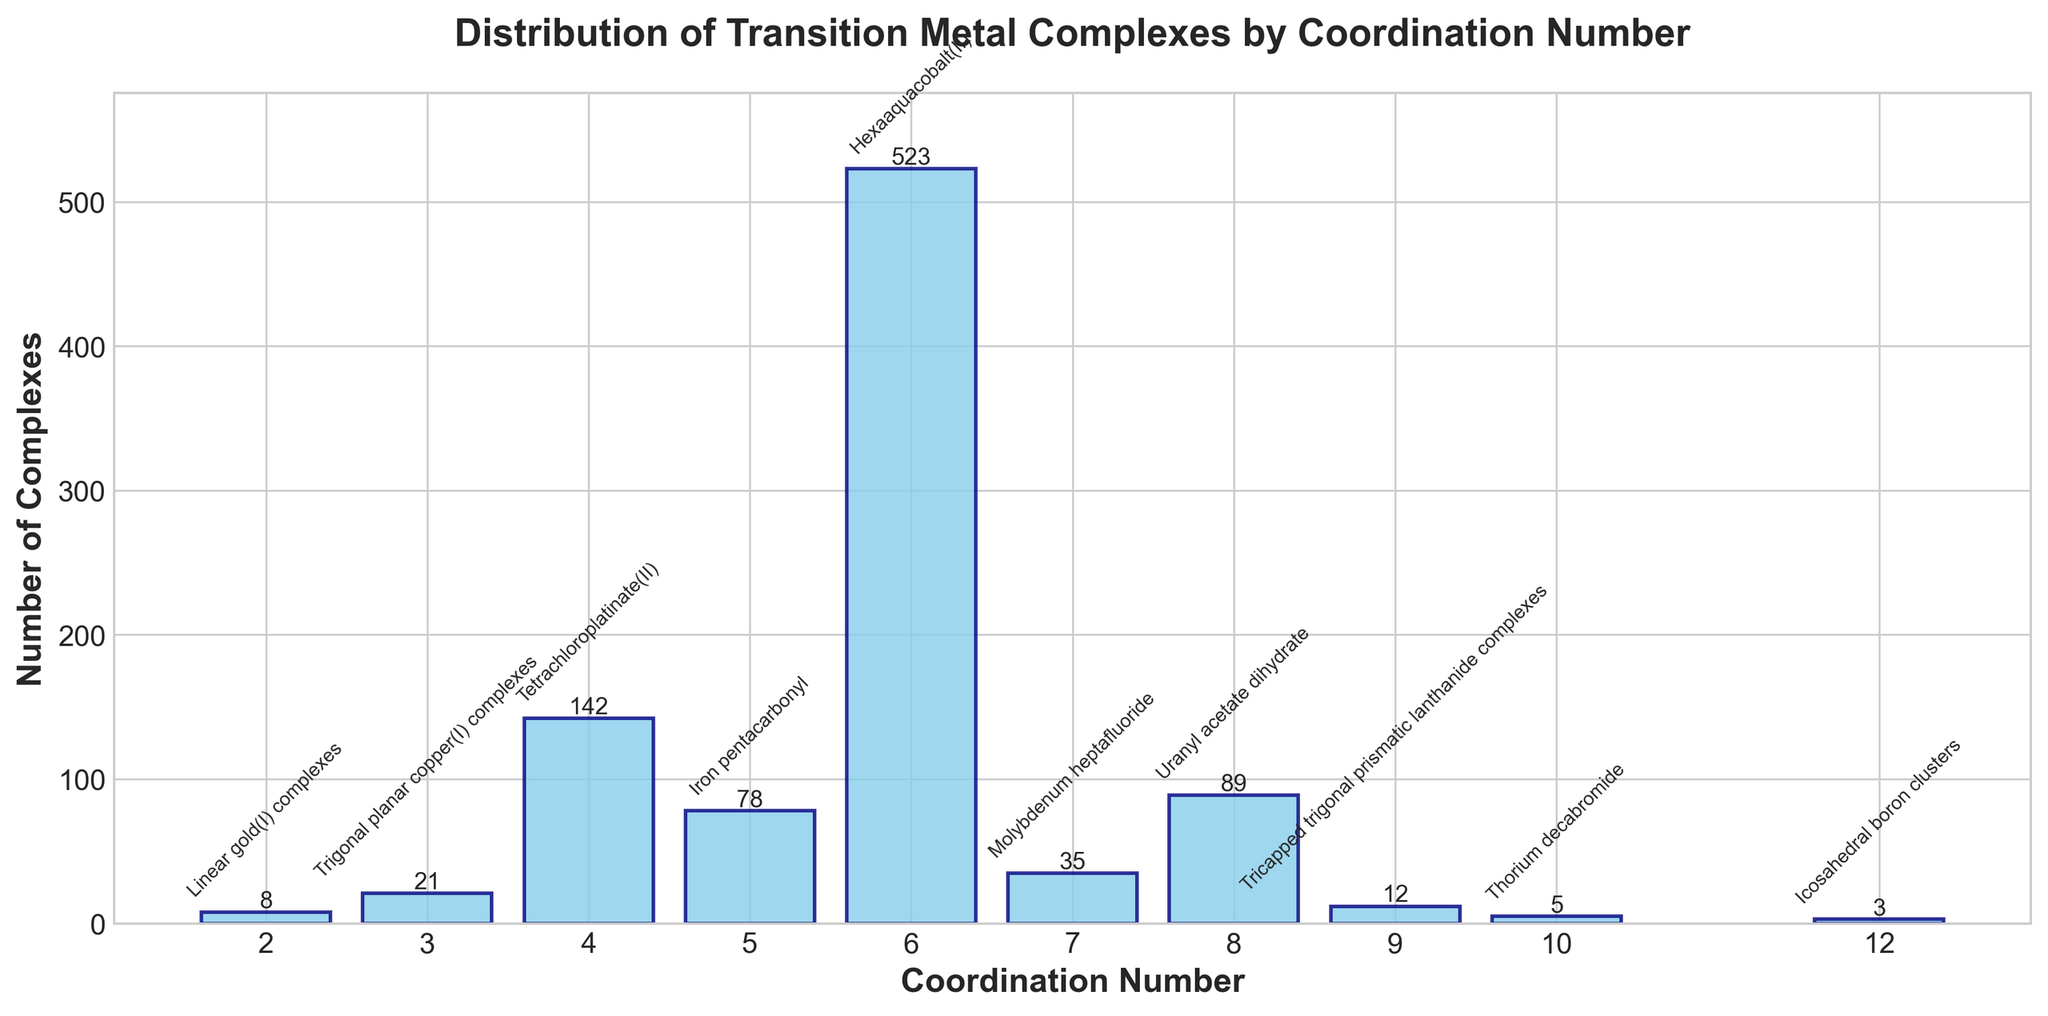What is the most common coordination number for transition metal complexes depicted in the figure? The tallest bar in the bar chart represents the most common coordination number. The bar at coordination number 6 is the highest, indicating that it has the most complexes.
Answer: 6 Which coordination numbers have fewer than 10 complexes? Observe the bars with heights less than 10 on the y-axis. Coordination numbers 2, 9, 10, and 12 each have fewer than 10 complexes.
Answer: 2, 9, 10, 12 How many more complexes are there with coordination number 4 than with coordination number 7? Find the heights of the bars for coordination numbers 4 and 7. Coordination number 4 has 142 complexes, and coordination number 7 has 35 complexes. Subtract the smaller number from the larger number: 142 - 35 = 107.
Answer: 107 What is the average number of complexes for coordination numbers 5, 7, and 8? To find the average, first sum the number of complexes for coordination numbers 5, 7, and 8, which are 78, 35, and 89, respectively. The total is 78 + 35 + 89 = 202. Divide by the number of coordination numbers (3): 202 / 3 ≈ 67.33.
Answer: 67.33 Which coordination number has example complex Iron pentacarbonyl, and how many complexes are there for this coordination number? Locate the annotation for Iron pentacarbonyl and identify its corresponding bar. It corresponds to coordination number 5, which has 78 complexes.
Answer: 5, 78 Is the sum of the complexes for coordination numbers 3 and 8 greater than the sum of the complexes for coordination numbers 4 and 5? Calculate the sum for each pair of coordination numbers. Coordination numbers 3 and 8 have 21 + 89 = 110 complexes. Coordination numbers 4 and 5 have 142 + 78 = 220 complexes. Compare the sums: 110 < 220.
Answer: No Which coordination number has the shortest bar, and what is the corresponding number of complexes? Find the bar with the smallest height. The shortest bar is for coordination number 12, which has 3 complexes.
Answer: 12, 3 How many coordination numbers have a number of complexes greater than 100? Identify the bars with heights greater than 100. Only coordination numbers 4 and 6 have more than 100 complexes. Thus, there are 2 such coordination numbers.
Answer: 2 By how much does the number of complexes for coordination number 6 exceed the combined number of complexes for coordination numbers 2, 10, and 12? Sum the number of complexes for coordination numbers 2, 10, and 12: 8 + 5 + 3 = 16. Compare this to the number of complexes for coordination number 6: 523 - 16 = 507.
Answer: 507 What visual attributes differentiate the bars in the chart? All bars are colored sky blue with navy edges. Each bar's height corresponds to the number of complexes for that coordination number, and the heights vary.
Answer: Color and Height 